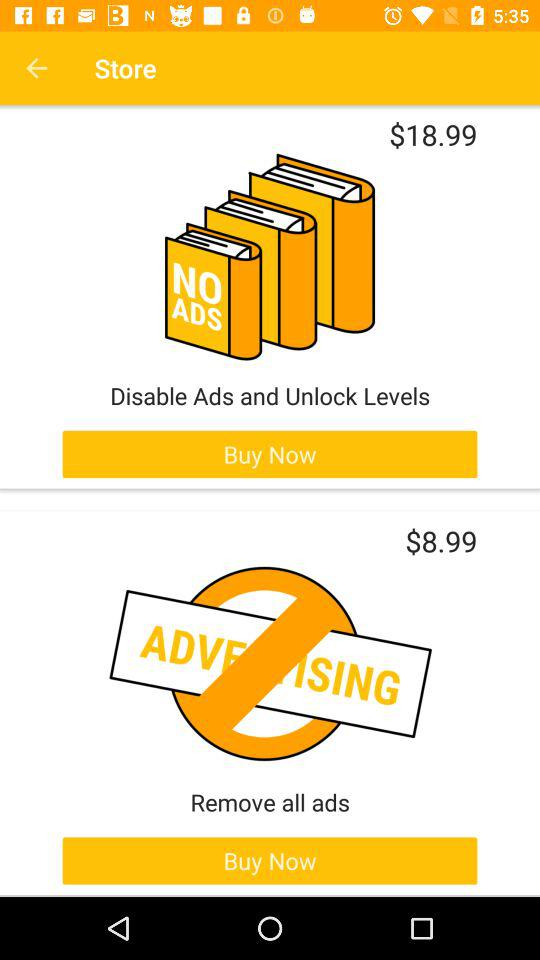What item has a price of $18.99? The item is "Disable Ads and Unlock Levels". 